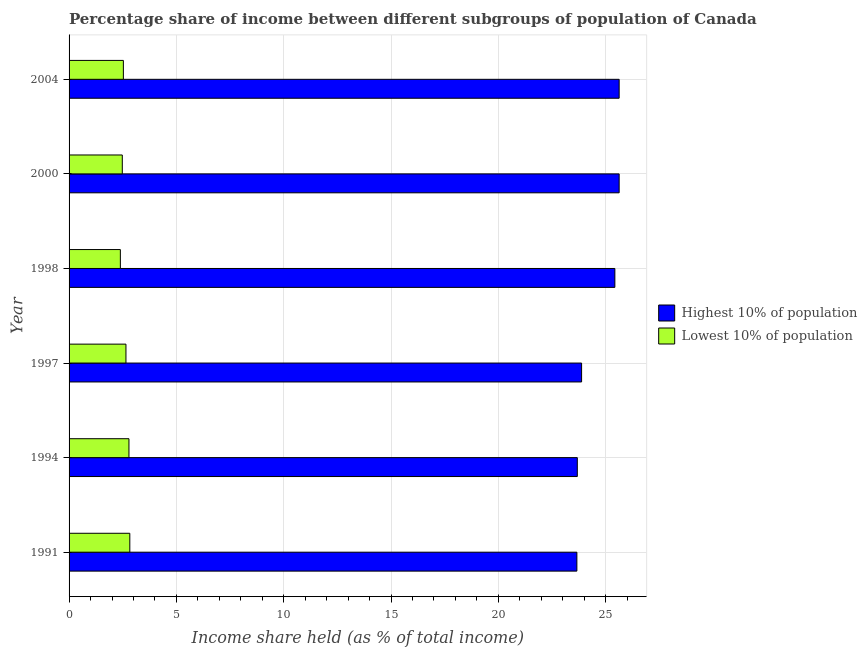How many different coloured bars are there?
Make the answer very short. 2. Are the number of bars per tick equal to the number of legend labels?
Your answer should be very brief. Yes. Are the number of bars on each tick of the Y-axis equal?
Make the answer very short. Yes. What is the label of the 5th group of bars from the top?
Offer a very short reply. 1994. What is the income share held by lowest 10% of the population in 2000?
Your answer should be very brief. 2.48. Across all years, what is the maximum income share held by lowest 10% of the population?
Your answer should be compact. 2.83. Across all years, what is the minimum income share held by highest 10% of the population?
Your answer should be compact. 23.66. In which year was the income share held by highest 10% of the population maximum?
Your response must be concise. 2000. In which year was the income share held by lowest 10% of the population minimum?
Offer a very short reply. 1998. What is the total income share held by lowest 10% of the population in the graph?
Offer a very short reply. 15.67. What is the difference between the income share held by highest 10% of the population in 1994 and that in 2004?
Your answer should be very brief. -1.95. What is the difference between the income share held by highest 10% of the population in 2000 and the income share held by lowest 10% of the population in 1998?
Provide a short and direct response. 23.24. What is the average income share held by lowest 10% of the population per year?
Provide a succinct answer. 2.61. In the year 2004, what is the difference between the income share held by highest 10% of the population and income share held by lowest 10% of the population?
Offer a very short reply. 23.1. In how many years, is the income share held by lowest 10% of the population greater than 16 %?
Your answer should be compact. 0. Is the income share held by lowest 10% of the population in 1997 less than that in 2000?
Offer a terse response. No. Is the difference between the income share held by highest 10% of the population in 1997 and 1998 greater than the difference between the income share held by lowest 10% of the population in 1997 and 1998?
Keep it short and to the point. No. What is the difference between the highest and the lowest income share held by highest 10% of the population?
Your answer should be compact. 1.97. In how many years, is the income share held by highest 10% of the population greater than the average income share held by highest 10% of the population taken over all years?
Make the answer very short. 3. What does the 2nd bar from the top in 2004 represents?
Provide a short and direct response. Highest 10% of population. What does the 1st bar from the bottom in 1998 represents?
Ensure brevity in your answer.  Highest 10% of population. How many bars are there?
Your answer should be compact. 12. Does the graph contain any zero values?
Offer a terse response. No. Where does the legend appear in the graph?
Provide a succinct answer. Center right. How many legend labels are there?
Give a very brief answer. 2. How are the legend labels stacked?
Offer a terse response. Vertical. What is the title of the graph?
Your response must be concise. Percentage share of income between different subgroups of population of Canada. Does "Methane" appear as one of the legend labels in the graph?
Offer a very short reply. No. What is the label or title of the X-axis?
Your answer should be very brief. Income share held (as % of total income). What is the label or title of the Y-axis?
Your answer should be very brief. Year. What is the Income share held (as % of total income) in Highest 10% of population in 1991?
Make the answer very short. 23.66. What is the Income share held (as % of total income) in Lowest 10% of population in 1991?
Your answer should be compact. 2.83. What is the Income share held (as % of total income) in Highest 10% of population in 1994?
Provide a succinct answer. 23.68. What is the Income share held (as % of total income) of Lowest 10% of population in 1994?
Your answer should be very brief. 2.79. What is the Income share held (as % of total income) of Highest 10% of population in 1997?
Ensure brevity in your answer.  23.88. What is the Income share held (as % of total income) in Lowest 10% of population in 1997?
Ensure brevity in your answer.  2.65. What is the Income share held (as % of total income) in Highest 10% of population in 1998?
Keep it short and to the point. 25.43. What is the Income share held (as % of total income) in Lowest 10% of population in 1998?
Give a very brief answer. 2.39. What is the Income share held (as % of total income) in Highest 10% of population in 2000?
Your response must be concise. 25.63. What is the Income share held (as % of total income) in Lowest 10% of population in 2000?
Your response must be concise. 2.48. What is the Income share held (as % of total income) of Highest 10% of population in 2004?
Provide a short and direct response. 25.63. What is the Income share held (as % of total income) in Lowest 10% of population in 2004?
Your answer should be compact. 2.53. Across all years, what is the maximum Income share held (as % of total income) of Highest 10% of population?
Your answer should be compact. 25.63. Across all years, what is the maximum Income share held (as % of total income) of Lowest 10% of population?
Your answer should be compact. 2.83. Across all years, what is the minimum Income share held (as % of total income) in Highest 10% of population?
Your response must be concise. 23.66. Across all years, what is the minimum Income share held (as % of total income) of Lowest 10% of population?
Give a very brief answer. 2.39. What is the total Income share held (as % of total income) of Highest 10% of population in the graph?
Offer a very short reply. 147.91. What is the total Income share held (as % of total income) of Lowest 10% of population in the graph?
Keep it short and to the point. 15.67. What is the difference between the Income share held (as % of total income) in Highest 10% of population in 1991 and that in 1994?
Offer a very short reply. -0.02. What is the difference between the Income share held (as % of total income) in Lowest 10% of population in 1991 and that in 1994?
Your response must be concise. 0.04. What is the difference between the Income share held (as % of total income) in Highest 10% of population in 1991 and that in 1997?
Your answer should be very brief. -0.22. What is the difference between the Income share held (as % of total income) of Lowest 10% of population in 1991 and that in 1997?
Provide a short and direct response. 0.18. What is the difference between the Income share held (as % of total income) of Highest 10% of population in 1991 and that in 1998?
Keep it short and to the point. -1.77. What is the difference between the Income share held (as % of total income) of Lowest 10% of population in 1991 and that in 1998?
Make the answer very short. 0.44. What is the difference between the Income share held (as % of total income) in Highest 10% of population in 1991 and that in 2000?
Give a very brief answer. -1.97. What is the difference between the Income share held (as % of total income) in Lowest 10% of population in 1991 and that in 2000?
Your answer should be compact. 0.35. What is the difference between the Income share held (as % of total income) of Highest 10% of population in 1991 and that in 2004?
Your answer should be compact. -1.97. What is the difference between the Income share held (as % of total income) of Highest 10% of population in 1994 and that in 1997?
Ensure brevity in your answer.  -0.2. What is the difference between the Income share held (as % of total income) of Lowest 10% of population in 1994 and that in 1997?
Make the answer very short. 0.14. What is the difference between the Income share held (as % of total income) of Highest 10% of population in 1994 and that in 1998?
Your response must be concise. -1.75. What is the difference between the Income share held (as % of total income) in Lowest 10% of population in 1994 and that in 1998?
Provide a short and direct response. 0.4. What is the difference between the Income share held (as % of total income) of Highest 10% of population in 1994 and that in 2000?
Ensure brevity in your answer.  -1.95. What is the difference between the Income share held (as % of total income) of Lowest 10% of population in 1994 and that in 2000?
Your answer should be compact. 0.31. What is the difference between the Income share held (as % of total income) in Highest 10% of population in 1994 and that in 2004?
Make the answer very short. -1.95. What is the difference between the Income share held (as % of total income) in Lowest 10% of population in 1994 and that in 2004?
Offer a very short reply. 0.26. What is the difference between the Income share held (as % of total income) in Highest 10% of population in 1997 and that in 1998?
Your answer should be very brief. -1.55. What is the difference between the Income share held (as % of total income) in Lowest 10% of population in 1997 and that in 1998?
Your answer should be very brief. 0.26. What is the difference between the Income share held (as % of total income) in Highest 10% of population in 1997 and that in 2000?
Your answer should be compact. -1.75. What is the difference between the Income share held (as % of total income) of Lowest 10% of population in 1997 and that in 2000?
Give a very brief answer. 0.17. What is the difference between the Income share held (as % of total income) in Highest 10% of population in 1997 and that in 2004?
Your response must be concise. -1.75. What is the difference between the Income share held (as % of total income) of Lowest 10% of population in 1997 and that in 2004?
Your answer should be compact. 0.12. What is the difference between the Income share held (as % of total income) of Highest 10% of population in 1998 and that in 2000?
Provide a short and direct response. -0.2. What is the difference between the Income share held (as % of total income) of Lowest 10% of population in 1998 and that in 2000?
Ensure brevity in your answer.  -0.09. What is the difference between the Income share held (as % of total income) in Highest 10% of population in 1998 and that in 2004?
Provide a succinct answer. -0.2. What is the difference between the Income share held (as % of total income) in Lowest 10% of population in 1998 and that in 2004?
Provide a short and direct response. -0.14. What is the difference between the Income share held (as % of total income) of Highest 10% of population in 2000 and that in 2004?
Give a very brief answer. 0. What is the difference between the Income share held (as % of total income) of Lowest 10% of population in 2000 and that in 2004?
Offer a terse response. -0.05. What is the difference between the Income share held (as % of total income) of Highest 10% of population in 1991 and the Income share held (as % of total income) of Lowest 10% of population in 1994?
Give a very brief answer. 20.87. What is the difference between the Income share held (as % of total income) in Highest 10% of population in 1991 and the Income share held (as % of total income) in Lowest 10% of population in 1997?
Your answer should be very brief. 21.01. What is the difference between the Income share held (as % of total income) of Highest 10% of population in 1991 and the Income share held (as % of total income) of Lowest 10% of population in 1998?
Make the answer very short. 21.27. What is the difference between the Income share held (as % of total income) in Highest 10% of population in 1991 and the Income share held (as % of total income) in Lowest 10% of population in 2000?
Make the answer very short. 21.18. What is the difference between the Income share held (as % of total income) of Highest 10% of population in 1991 and the Income share held (as % of total income) of Lowest 10% of population in 2004?
Your answer should be compact. 21.13. What is the difference between the Income share held (as % of total income) in Highest 10% of population in 1994 and the Income share held (as % of total income) in Lowest 10% of population in 1997?
Give a very brief answer. 21.03. What is the difference between the Income share held (as % of total income) in Highest 10% of population in 1994 and the Income share held (as % of total income) in Lowest 10% of population in 1998?
Make the answer very short. 21.29. What is the difference between the Income share held (as % of total income) in Highest 10% of population in 1994 and the Income share held (as % of total income) in Lowest 10% of population in 2000?
Provide a succinct answer. 21.2. What is the difference between the Income share held (as % of total income) of Highest 10% of population in 1994 and the Income share held (as % of total income) of Lowest 10% of population in 2004?
Provide a succinct answer. 21.15. What is the difference between the Income share held (as % of total income) in Highest 10% of population in 1997 and the Income share held (as % of total income) in Lowest 10% of population in 1998?
Provide a short and direct response. 21.49. What is the difference between the Income share held (as % of total income) of Highest 10% of population in 1997 and the Income share held (as % of total income) of Lowest 10% of population in 2000?
Keep it short and to the point. 21.4. What is the difference between the Income share held (as % of total income) of Highest 10% of population in 1997 and the Income share held (as % of total income) of Lowest 10% of population in 2004?
Ensure brevity in your answer.  21.35. What is the difference between the Income share held (as % of total income) in Highest 10% of population in 1998 and the Income share held (as % of total income) in Lowest 10% of population in 2000?
Provide a succinct answer. 22.95. What is the difference between the Income share held (as % of total income) in Highest 10% of population in 1998 and the Income share held (as % of total income) in Lowest 10% of population in 2004?
Make the answer very short. 22.9. What is the difference between the Income share held (as % of total income) in Highest 10% of population in 2000 and the Income share held (as % of total income) in Lowest 10% of population in 2004?
Provide a succinct answer. 23.1. What is the average Income share held (as % of total income) in Highest 10% of population per year?
Your response must be concise. 24.65. What is the average Income share held (as % of total income) of Lowest 10% of population per year?
Make the answer very short. 2.61. In the year 1991, what is the difference between the Income share held (as % of total income) of Highest 10% of population and Income share held (as % of total income) of Lowest 10% of population?
Your answer should be very brief. 20.83. In the year 1994, what is the difference between the Income share held (as % of total income) of Highest 10% of population and Income share held (as % of total income) of Lowest 10% of population?
Keep it short and to the point. 20.89. In the year 1997, what is the difference between the Income share held (as % of total income) of Highest 10% of population and Income share held (as % of total income) of Lowest 10% of population?
Offer a terse response. 21.23. In the year 1998, what is the difference between the Income share held (as % of total income) of Highest 10% of population and Income share held (as % of total income) of Lowest 10% of population?
Offer a very short reply. 23.04. In the year 2000, what is the difference between the Income share held (as % of total income) in Highest 10% of population and Income share held (as % of total income) in Lowest 10% of population?
Offer a very short reply. 23.15. In the year 2004, what is the difference between the Income share held (as % of total income) in Highest 10% of population and Income share held (as % of total income) in Lowest 10% of population?
Provide a succinct answer. 23.1. What is the ratio of the Income share held (as % of total income) in Highest 10% of population in 1991 to that in 1994?
Provide a short and direct response. 1. What is the ratio of the Income share held (as % of total income) of Lowest 10% of population in 1991 to that in 1994?
Provide a short and direct response. 1.01. What is the ratio of the Income share held (as % of total income) of Highest 10% of population in 1991 to that in 1997?
Offer a very short reply. 0.99. What is the ratio of the Income share held (as % of total income) in Lowest 10% of population in 1991 to that in 1997?
Provide a succinct answer. 1.07. What is the ratio of the Income share held (as % of total income) in Highest 10% of population in 1991 to that in 1998?
Your response must be concise. 0.93. What is the ratio of the Income share held (as % of total income) in Lowest 10% of population in 1991 to that in 1998?
Provide a short and direct response. 1.18. What is the ratio of the Income share held (as % of total income) in Lowest 10% of population in 1991 to that in 2000?
Give a very brief answer. 1.14. What is the ratio of the Income share held (as % of total income) in Highest 10% of population in 1991 to that in 2004?
Keep it short and to the point. 0.92. What is the ratio of the Income share held (as % of total income) of Lowest 10% of population in 1991 to that in 2004?
Provide a short and direct response. 1.12. What is the ratio of the Income share held (as % of total income) of Lowest 10% of population in 1994 to that in 1997?
Provide a succinct answer. 1.05. What is the ratio of the Income share held (as % of total income) of Highest 10% of population in 1994 to that in 1998?
Your answer should be very brief. 0.93. What is the ratio of the Income share held (as % of total income) in Lowest 10% of population in 1994 to that in 1998?
Make the answer very short. 1.17. What is the ratio of the Income share held (as % of total income) of Highest 10% of population in 1994 to that in 2000?
Keep it short and to the point. 0.92. What is the ratio of the Income share held (as % of total income) in Lowest 10% of population in 1994 to that in 2000?
Offer a terse response. 1.12. What is the ratio of the Income share held (as % of total income) of Highest 10% of population in 1994 to that in 2004?
Provide a succinct answer. 0.92. What is the ratio of the Income share held (as % of total income) in Lowest 10% of population in 1994 to that in 2004?
Your response must be concise. 1.1. What is the ratio of the Income share held (as % of total income) in Highest 10% of population in 1997 to that in 1998?
Provide a succinct answer. 0.94. What is the ratio of the Income share held (as % of total income) in Lowest 10% of population in 1997 to that in 1998?
Your answer should be compact. 1.11. What is the ratio of the Income share held (as % of total income) in Highest 10% of population in 1997 to that in 2000?
Keep it short and to the point. 0.93. What is the ratio of the Income share held (as % of total income) of Lowest 10% of population in 1997 to that in 2000?
Make the answer very short. 1.07. What is the ratio of the Income share held (as % of total income) of Highest 10% of population in 1997 to that in 2004?
Offer a terse response. 0.93. What is the ratio of the Income share held (as % of total income) of Lowest 10% of population in 1997 to that in 2004?
Provide a short and direct response. 1.05. What is the ratio of the Income share held (as % of total income) of Highest 10% of population in 1998 to that in 2000?
Your answer should be compact. 0.99. What is the ratio of the Income share held (as % of total income) of Lowest 10% of population in 1998 to that in 2000?
Provide a succinct answer. 0.96. What is the ratio of the Income share held (as % of total income) in Lowest 10% of population in 1998 to that in 2004?
Your answer should be compact. 0.94. What is the ratio of the Income share held (as % of total income) of Lowest 10% of population in 2000 to that in 2004?
Your response must be concise. 0.98. What is the difference between the highest and the second highest Income share held (as % of total income) in Highest 10% of population?
Give a very brief answer. 0. What is the difference between the highest and the lowest Income share held (as % of total income) of Highest 10% of population?
Ensure brevity in your answer.  1.97. What is the difference between the highest and the lowest Income share held (as % of total income) in Lowest 10% of population?
Keep it short and to the point. 0.44. 